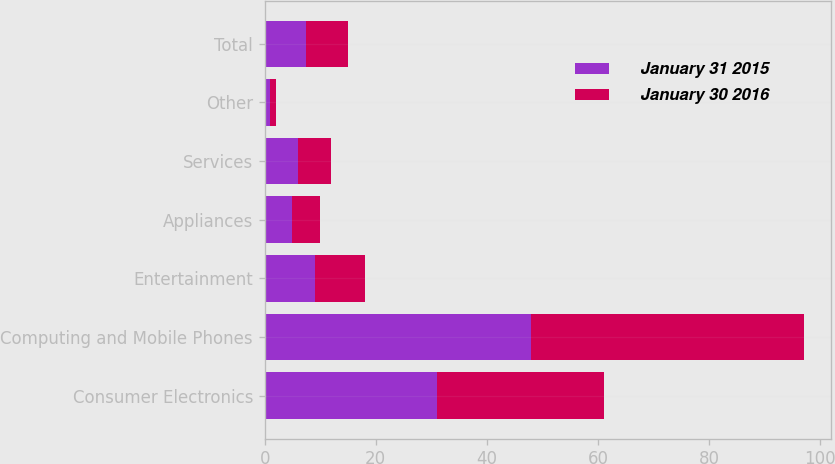Convert chart. <chart><loc_0><loc_0><loc_500><loc_500><stacked_bar_chart><ecel><fcel>Consumer Electronics<fcel>Computing and Mobile Phones<fcel>Entertainment<fcel>Appliances<fcel>Services<fcel>Other<fcel>Total<nl><fcel>January 31 2015<fcel>31<fcel>48<fcel>9<fcel>5<fcel>6<fcel>1<fcel>7.5<nl><fcel>January 30 2016<fcel>30<fcel>49<fcel>9<fcel>5<fcel>6<fcel>1<fcel>7.5<nl></chart> 